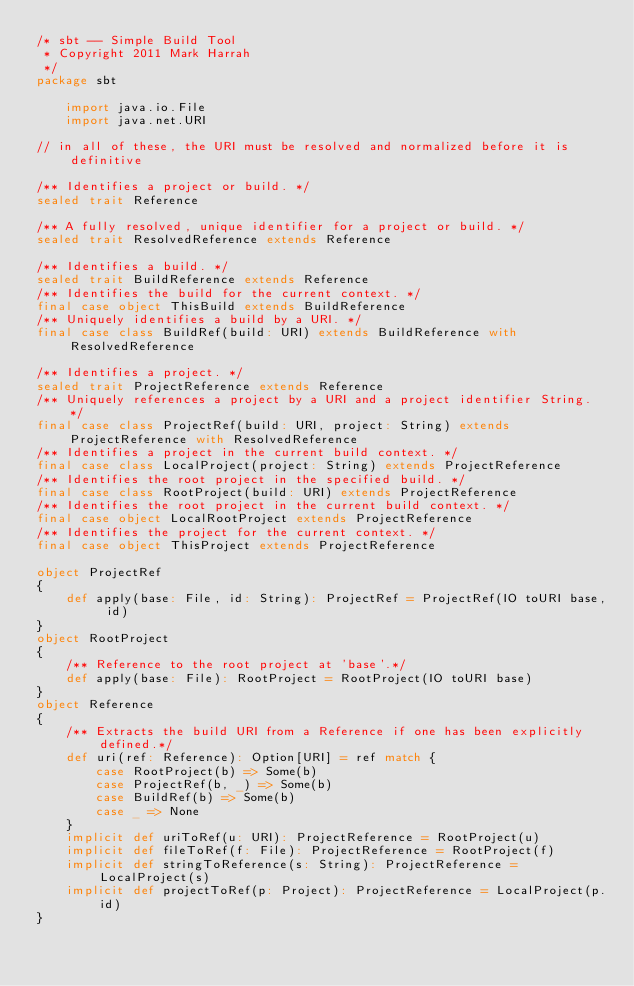Convert code to text. <code><loc_0><loc_0><loc_500><loc_500><_Scala_>/* sbt -- Simple Build Tool
 * Copyright 2011 Mark Harrah
 */
package sbt

	import java.io.File
	import java.net.URI

// in all of these, the URI must be resolved and normalized before it is definitive

/** Identifies a project or build. */
sealed trait Reference

/** A fully resolved, unique identifier for a project or build. */
sealed trait ResolvedReference extends Reference

/** Identifies a build. */
sealed trait BuildReference extends Reference
/** Identifies the build for the current context. */
final case object ThisBuild extends BuildReference
/** Uniquely identifies a build by a URI. */
final case class BuildRef(build: URI) extends BuildReference with ResolvedReference

/** Identifies a project. */
sealed trait ProjectReference extends Reference
/** Uniquely references a project by a URI and a project identifier String. */
final case class ProjectRef(build: URI, project: String) extends ProjectReference with ResolvedReference
/** Identifies a project in the current build context. */
final case class LocalProject(project: String) extends ProjectReference
/** Identifies the root project in the specified build. */
final case class RootProject(build: URI) extends ProjectReference
/** Identifies the root project in the current build context. */
final case object LocalRootProject extends ProjectReference
/** Identifies the project for the current context. */
final case object ThisProject extends ProjectReference

object ProjectRef
{
	def apply(base: File, id: String): ProjectRef = ProjectRef(IO toURI base, id)
}
object RootProject
{
	/** Reference to the root project at 'base'.*/
	def apply(base: File): RootProject = RootProject(IO toURI base)
}
object Reference
{
	/** Extracts the build URI from a Reference if one has been explicitly defined.*/
	def uri(ref: Reference): Option[URI] = ref match {
		case RootProject(b) => Some(b)
		case ProjectRef(b, _) => Some(b)
		case BuildRef(b) => Some(b)
		case _ => None
	}
	implicit def uriToRef(u: URI): ProjectReference = RootProject(u)
	implicit def fileToRef(f: File): ProjectReference = RootProject(f)
	implicit def stringToReference(s: String): ProjectReference = LocalProject(s)
	implicit def projectToRef(p: Project): ProjectReference = LocalProject(p.id)
}</code> 